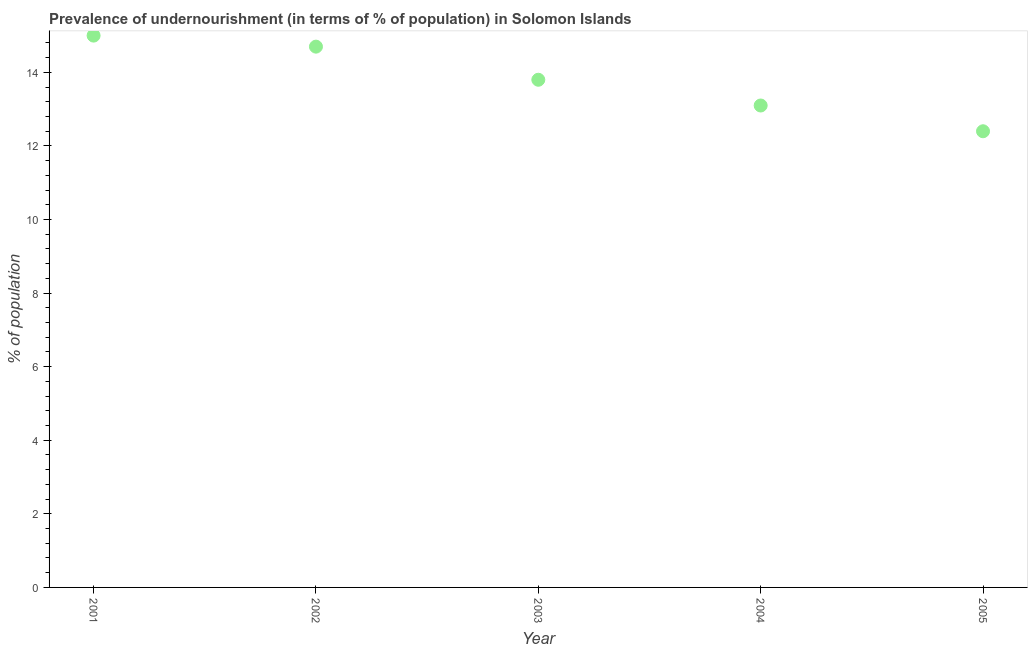What is the percentage of undernourished population in 2001?
Give a very brief answer. 15. Across all years, what is the maximum percentage of undernourished population?
Your answer should be very brief. 15. What is the sum of the percentage of undernourished population?
Offer a very short reply. 69. What is the difference between the percentage of undernourished population in 2001 and 2003?
Keep it short and to the point. 1.2. What is the ratio of the percentage of undernourished population in 2004 to that in 2005?
Your answer should be compact. 1.06. Is the percentage of undernourished population in 2002 less than that in 2005?
Provide a succinct answer. No. What is the difference between the highest and the second highest percentage of undernourished population?
Keep it short and to the point. 0.3. Is the sum of the percentage of undernourished population in 2002 and 2005 greater than the maximum percentage of undernourished population across all years?
Give a very brief answer. Yes. What is the difference between the highest and the lowest percentage of undernourished population?
Make the answer very short. 2.6. In how many years, is the percentage of undernourished population greater than the average percentage of undernourished population taken over all years?
Offer a terse response. 2. How many years are there in the graph?
Provide a short and direct response. 5. What is the difference between two consecutive major ticks on the Y-axis?
Keep it short and to the point. 2. Does the graph contain grids?
Provide a short and direct response. No. What is the title of the graph?
Your answer should be very brief. Prevalence of undernourishment (in terms of % of population) in Solomon Islands. What is the label or title of the X-axis?
Your answer should be very brief. Year. What is the label or title of the Y-axis?
Give a very brief answer. % of population. What is the % of population in 2001?
Make the answer very short. 15. What is the % of population in 2002?
Offer a terse response. 14.7. What is the % of population in 2004?
Make the answer very short. 13.1. What is the difference between the % of population in 2001 and 2002?
Ensure brevity in your answer.  0.3. What is the difference between the % of population in 2002 and 2003?
Ensure brevity in your answer.  0.9. What is the difference between the % of population in 2003 and 2005?
Offer a terse response. 1.4. What is the ratio of the % of population in 2001 to that in 2003?
Make the answer very short. 1.09. What is the ratio of the % of population in 2001 to that in 2004?
Your answer should be compact. 1.15. What is the ratio of the % of population in 2001 to that in 2005?
Provide a short and direct response. 1.21. What is the ratio of the % of population in 2002 to that in 2003?
Your answer should be very brief. 1.06. What is the ratio of the % of population in 2002 to that in 2004?
Your answer should be compact. 1.12. What is the ratio of the % of population in 2002 to that in 2005?
Ensure brevity in your answer.  1.19. What is the ratio of the % of population in 2003 to that in 2004?
Keep it short and to the point. 1.05. What is the ratio of the % of population in 2003 to that in 2005?
Ensure brevity in your answer.  1.11. What is the ratio of the % of population in 2004 to that in 2005?
Offer a terse response. 1.06. 